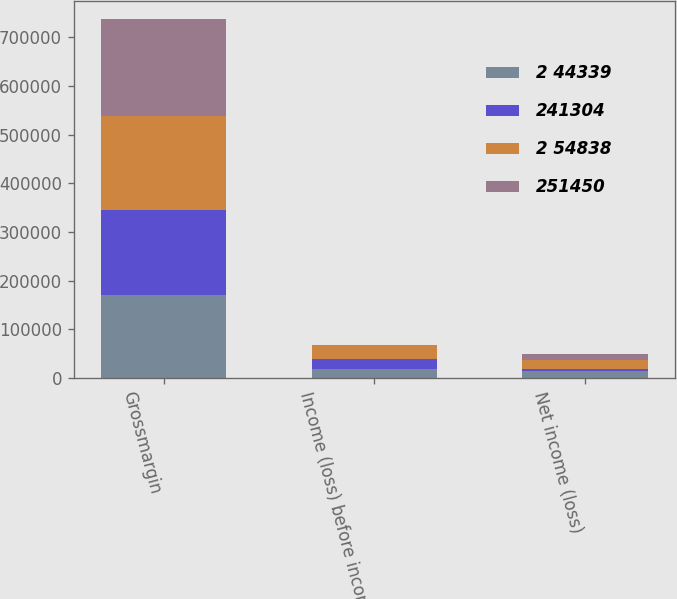Convert chart to OTSL. <chart><loc_0><loc_0><loc_500><loc_500><stacked_bar_chart><ecel><fcel>Grossmargin<fcel>Income (loss) before income<fcel>Net income (loss)<nl><fcel>2 44339<fcel>171329<fcel>19154<fcel>14325<nl><fcel>241304<fcel>174616<fcel>19006<fcel>4972<nl><fcel>2 54838<fcel>192085<fcel>29584<fcel>17294<nl><fcel>251450<fcel>199514<fcel>787<fcel>13475<nl></chart> 